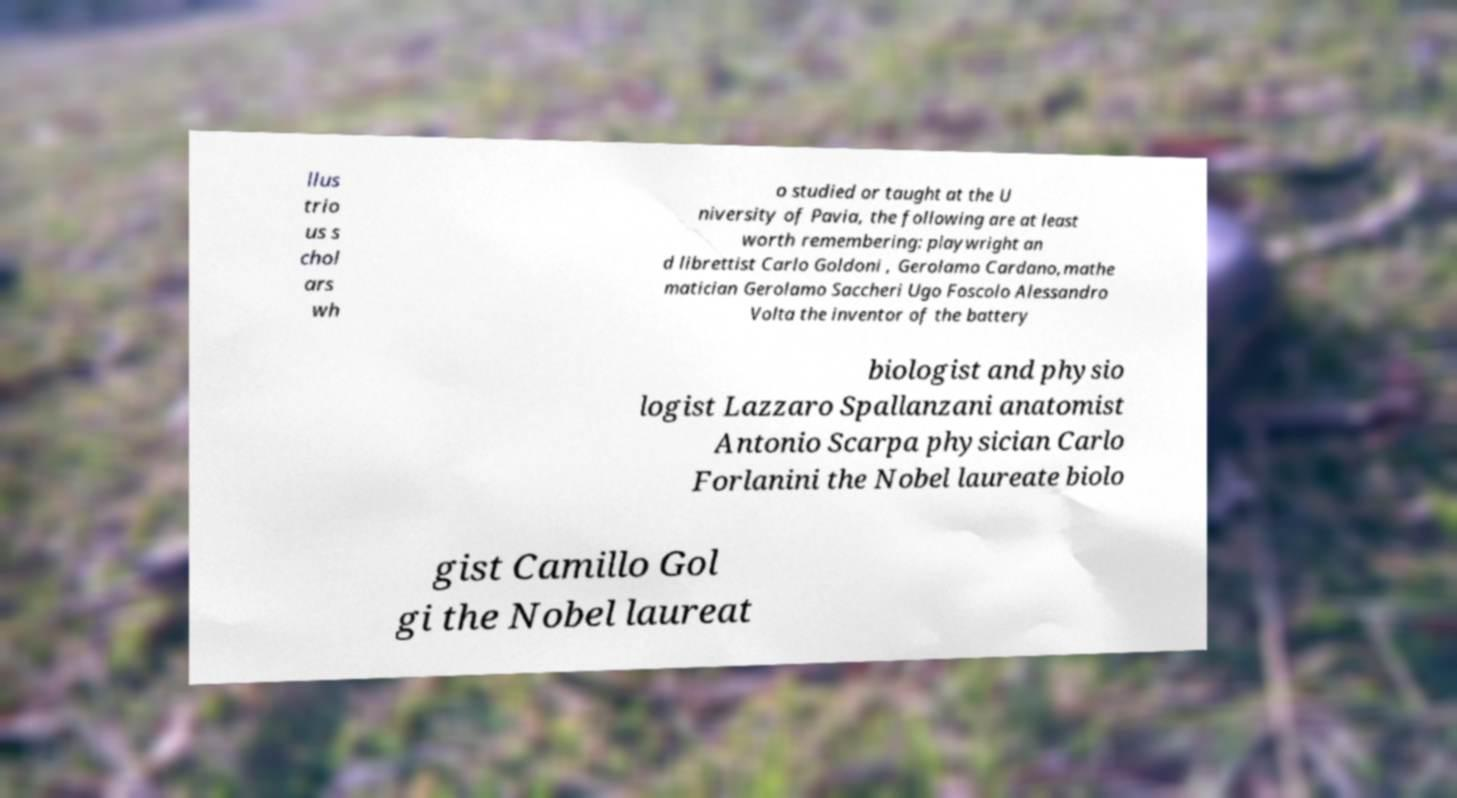Could you extract and type out the text from this image? llus trio us s chol ars wh o studied or taught at the U niversity of Pavia, the following are at least worth remembering: playwright an d librettist Carlo Goldoni , Gerolamo Cardano,mathe matician Gerolamo Saccheri Ugo Foscolo Alessandro Volta the inventor of the battery biologist and physio logist Lazzaro Spallanzani anatomist Antonio Scarpa physician Carlo Forlanini the Nobel laureate biolo gist Camillo Gol gi the Nobel laureat 